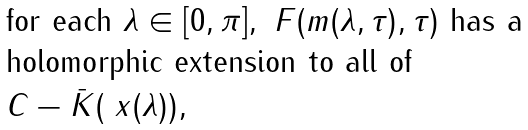Convert formula to latex. <formula><loc_0><loc_0><loc_500><loc_500>\begin{array} { l } \text {for each } \lambda \in [ 0 , \pi ] , \ F ( m ( \lambda , \tau ) , \tau ) \text { has a } \\ \text {holomorphic extension to all of } \\ C - \bar { K } ( \ x ( \lambda ) ) , \end{array}</formula> 